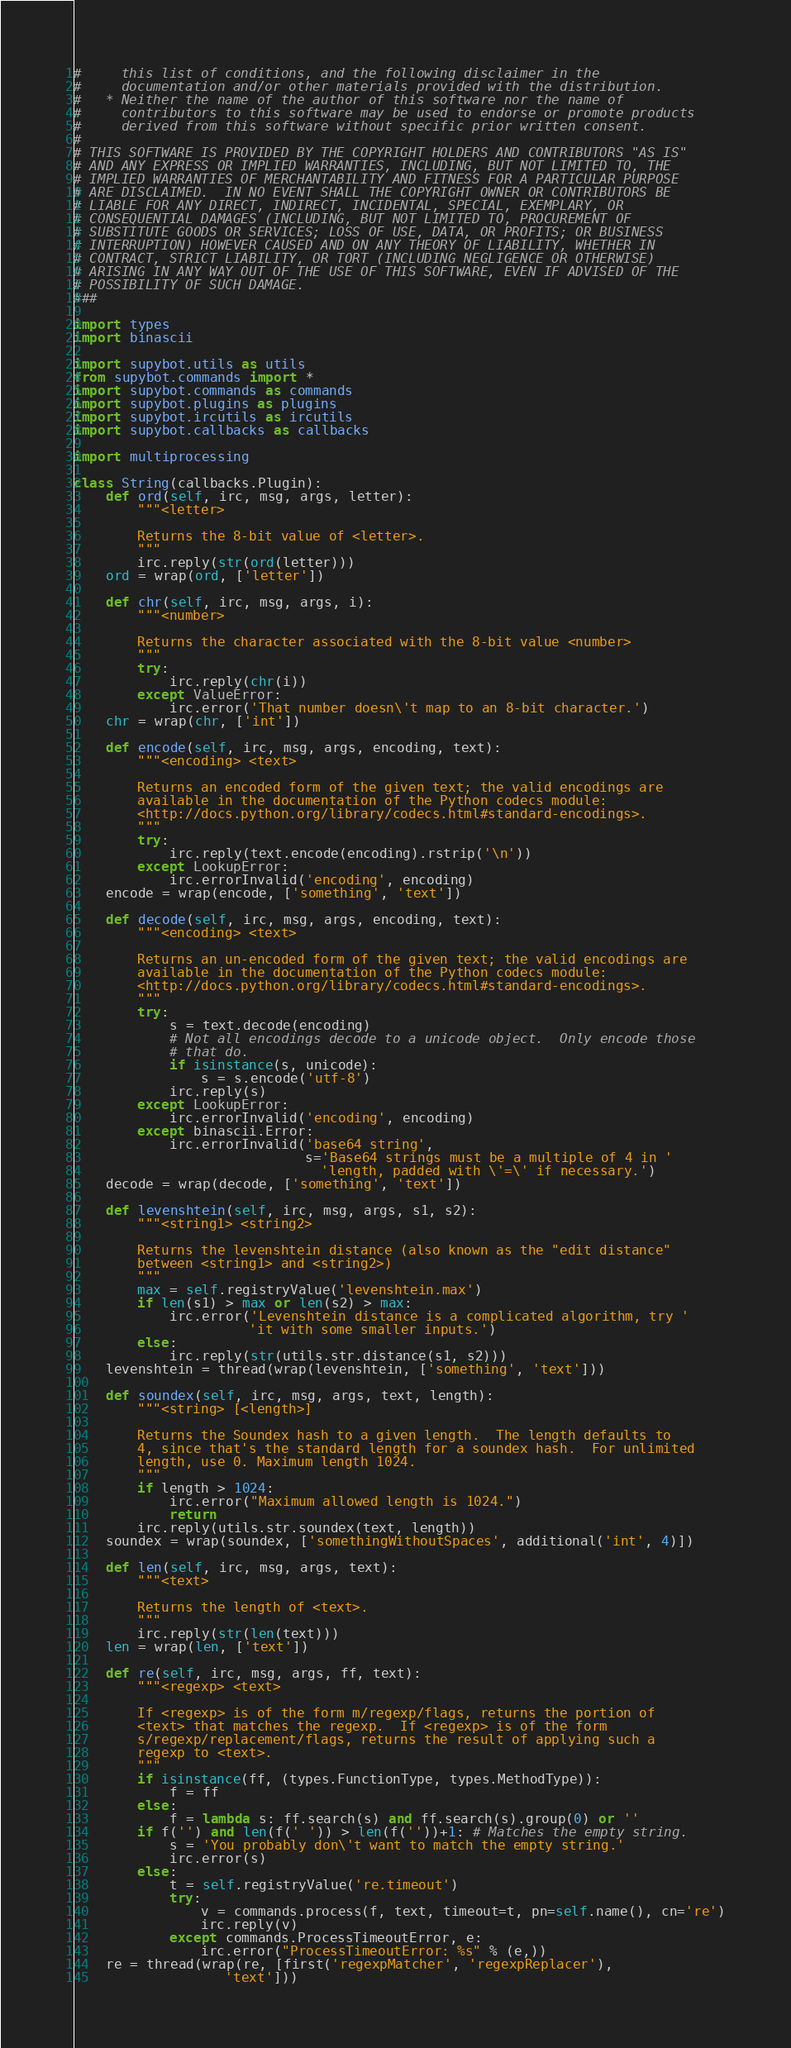<code> <loc_0><loc_0><loc_500><loc_500><_Python_>#     this list of conditions, and the following disclaimer in the
#     documentation and/or other materials provided with the distribution.
#   * Neither the name of the author of this software nor the name of
#     contributors to this software may be used to endorse or promote products
#     derived from this software without specific prior written consent.
#
# THIS SOFTWARE IS PROVIDED BY THE COPYRIGHT HOLDERS AND CONTRIBUTORS "AS IS"
# AND ANY EXPRESS OR IMPLIED WARRANTIES, INCLUDING, BUT NOT LIMITED TO, THE
# IMPLIED WARRANTIES OF MERCHANTABILITY AND FITNESS FOR A PARTICULAR PURPOSE
# ARE DISCLAIMED.  IN NO EVENT SHALL THE COPYRIGHT OWNER OR CONTRIBUTORS BE
# LIABLE FOR ANY DIRECT, INDIRECT, INCIDENTAL, SPECIAL, EXEMPLARY, OR
# CONSEQUENTIAL DAMAGES (INCLUDING, BUT NOT LIMITED TO, PROCUREMENT OF
# SUBSTITUTE GOODS OR SERVICES; LOSS OF USE, DATA, OR PROFITS; OR BUSINESS
# INTERRUPTION) HOWEVER CAUSED AND ON ANY THEORY OF LIABILITY, WHETHER IN
# CONTRACT, STRICT LIABILITY, OR TORT (INCLUDING NEGLIGENCE OR OTHERWISE)
# ARISING IN ANY WAY OUT OF THE USE OF THIS SOFTWARE, EVEN IF ADVISED OF THE
# POSSIBILITY OF SUCH DAMAGE.
###

import types
import binascii

import supybot.utils as utils
from supybot.commands import *
import supybot.commands as commands
import supybot.plugins as plugins
import supybot.ircutils as ircutils
import supybot.callbacks as callbacks

import multiprocessing

class String(callbacks.Plugin):
    def ord(self, irc, msg, args, letter):
        """<letter>

        Returns the 8-bit value of <letter>.
        """
        irc.reply(str(ord(letter)))
    ord = wrap(ord, ['letter'])

    def chr(self, irc, msg, args, i):
        """<number>

        Returns the character associated with the 8-bit value <number>
        """
        try:
            irc.reply(chr(i))
        except ValueError:
            irc.error('That number doesn\'t map to an 8-bit character.')
    chr = wrap(chr, ['int'])

    def encode(self, irc, msg, args, encoding, text):
        """<encoding> <text>

        Returns an encoded form of the given text; the valid encodings are
        available in the documentation of the Python codecs module:
        <http://docs.python.org/library/codecs.html#standard-encodings>.
        """
        try:
            irc.reply(text.encode(encoding).rstrip('\n'))
        except LookupError:
            irc.errorInvalid('encoding', encoding)
    encode = wrap(encode, ['something', 'text'])

    def decode(self, irc, msg, args, encoding, text):
        """<encoding> <text>

        Returns an un-encoded form of the given text; the valid encodings are
        available in the documentation of the Python codecs module:
        <http://docs.python.org/library/codecs.html#standard-encodings>.
        """
        try:
            s = text.decode(encoding)
            # Not all encodings decode to a unicode object.  Only encode those
            # that do.
            if isinstance(s, unicode):
                s = s.encode('utf-8')
            irc.reply(s)
        except LookupError:
            irc.errorInvalid('encoding', encoding)
        except binascii.Error:
            irc.errorInvalid('base64 string',
                             s='Base64 strings must be a multiple of 4 in '
                               'length, padded with \'=\' if necessary.')
    decode = wrap(decode, ['something', 'text'])

    def levenshtein(self, irc, msg, args, s1, s2):
        """<string1> <string2>

        Returns the levenshtein distance (also known as the "edit distance"
        between <string1> and <string2>)
        """
        max = self.registryValue('levenshtein.max')
        if len(s1) > max or len(s2) > max:
            irc.error('Levenshtein distance is a complicated algorithm, try '
                      'it with some smaller inputs.')
        else:
            irc.reply(str(utils.str.distance(s1, s2)))
    levenshtein = thread(wrap(levenshtein, ['something', 'text']))

    def soundex(self, irc, msg, args, text, length):
        """<string> [<length>]

        Returns the Soundex hash to a given length.  The length defaults to
        4, since that's the standard length for a soundex hash.  For unlimited
        length, use 0. Maximum length 1024.
        """
        if length > 1024:
            irc.error("Maximum allowed length is 1024.")
            return
        irc.reply(utils.str.soundex(text, length))
    soundex = wrap(soundex, ['somethingWithoutSpaces', additional('int', 4)])

    def len(self, irc, msg, args, text):
        """<text>

        Returns the length of <text>.
        """
        irc.reply(str(len(text)))
    len = wrap(len, ['text'])

    def re(self, irc, msg, args, ff, text):
        """<regexp> <text>

        If <regexp> is of the form m/regexp/flags, returns the portion of
        <text> that matches the regexp.  If <regexp> is of the form
        s/regexp/replacement/flags, returns the result of applying such a
        regexp to <text>.
        """
        if isinstance(ff, (types.FunctionType, types.MethodType)):
            f = ff
        else:
            f = lambda s: ff.search(s) and ff.search(s).group(0) or ''
        if f('') and len(f(' ')) > len(f(''))+1: # Matches the empty string.
            s = 'You probably don\'t want to match the empty string.'
            irc.error(s)
        else:
            t = self.registryValue('re.timeout')
            try:
                v = commands.process(f, text, timeout=t, pn=self.name(), cn='re')
                irc.reply(v)
            except commands.ProcessTimeoutError, e:
                irc.error("ProcessTimeoutError: %s" % (e,))
    re = thread(wrap(re, [first('regexpMatcher', 'regexpReplacer'),
                   'text']))
</code> 